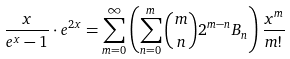Convert formula to latex. <formula><loc_0><loc_0><loc_500><loc_500>& \frac { x } { e ^ { x } - 1 } \cdot e ^ { 2 x } = \sum _ { m = 0 } ^ { \infty } \left ( \sum _ { n = 0 } ^ { m } { m \choose n } 2 ^ { m - n } B _ { n } \right ) \frac { x ^ { m } } { m ! }</formula> 